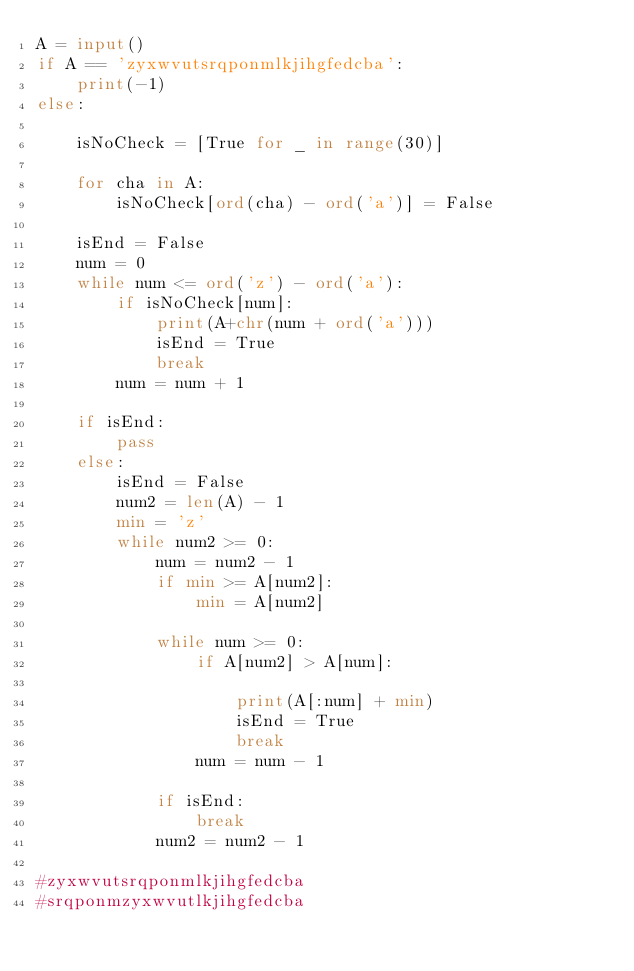<code> <loc_0><loc_0><loc_500><loc_500><_Python_>A = input()
if A == 'zyxwvutsrqponmlkjihgfedcba':
    print(-1)
else:

    isNoCheck = [True for _ in range(30)]

    for cha in A:
        isNoCheck[ord(cha) - ord('a')] = False

    isEnd = False
    num = 0
    while num <= ord('z') - ord('a'):
        if isNoCheck[num]:
            print(A+chr(num + ord('a')))
            isEnd = True
            break
        num = num + 1

    if isEnd:
        pass
    else:
        isEnd = False
        num2 = len(A) - 1
        min = 'z'
        while num2 >= 0:
            num = num2 - 1
            if min >= A[num2]:
                min = A[num2]

            while num >= 0:
                if A[num2] > A[num]:

                    print(A[:num] + min)
                    isEnd = True
                    break
                num = num - 1

            if isEnd:
                break
            num2 = num2 - 1

#zyxwvutsrqponmlkjihgfedcba
#srqponmzyxwvutlkjihgfedcba
</code> 